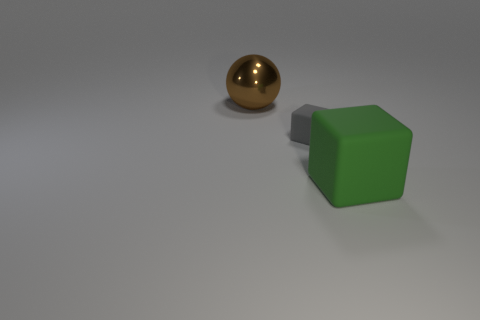There is a rubber thing behind the large thing that is in front of the thing that is to the left of the small gray object; what is its shape?
Your answer should be very brief. Cube. The other green rubber object that is the same shape as the small rubber thing is what size?
Keep it short and to the point. Large. What is the size of the thing that is to the right of the metallic ball and to the left of the big cube?
Your answer should be very brief. Small. The metal thing has what color?
Keep it short and to the point. Brown. There is a rubber thing behind the large green cube; what is its size?
Your answer should be very brief. Small. What number of matte blocks are left of the large object that is in front of the big thing that is to the left of the green rubber block?
Make the answer very short. 1. The large thing left of the block that is behind the green object is what color?
Provide a short and direct response. Brown. Are there any brown metal blocks of the same size as the gray thing?
Provide a short and direct response. No. What material is the big thing on the left side of the big thing in front of the object on the left side of the tiny cube?
Your answer should be very brief. Metal. There is a big rubber block that is right of the gray block; how many brown objects are to the left of it?
Your response must be concise. 1. 